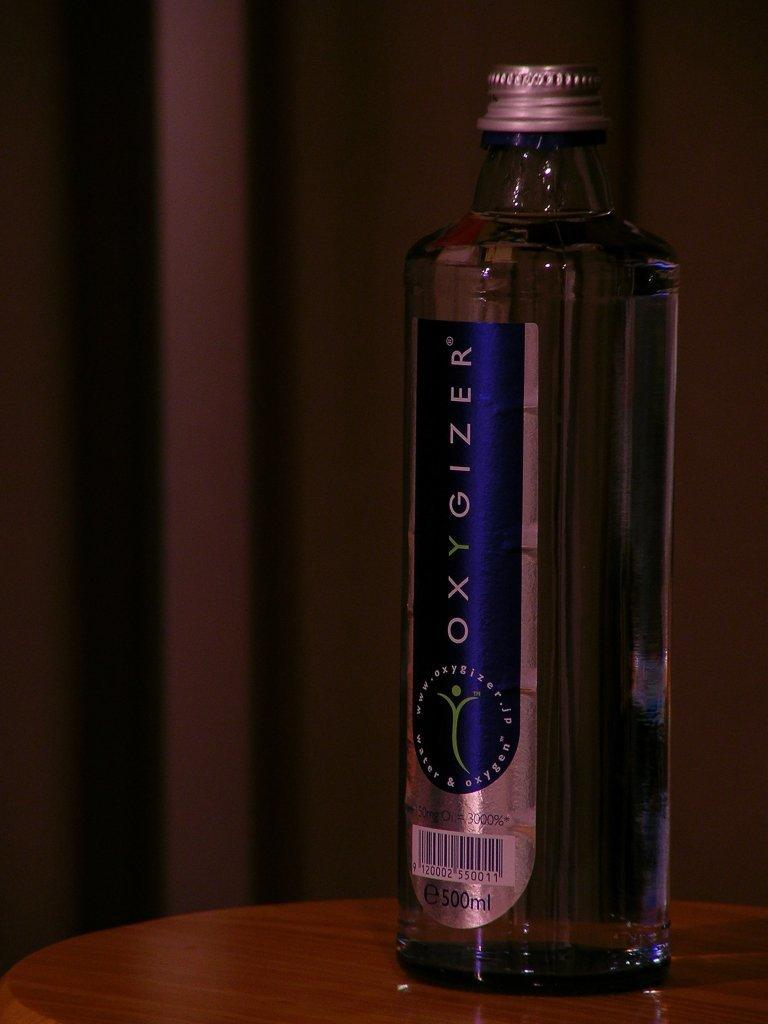<image>
Create a compact narrative representing the image presented. a bottle of 500 ml Oxygizer filled with water and oxegyn. 